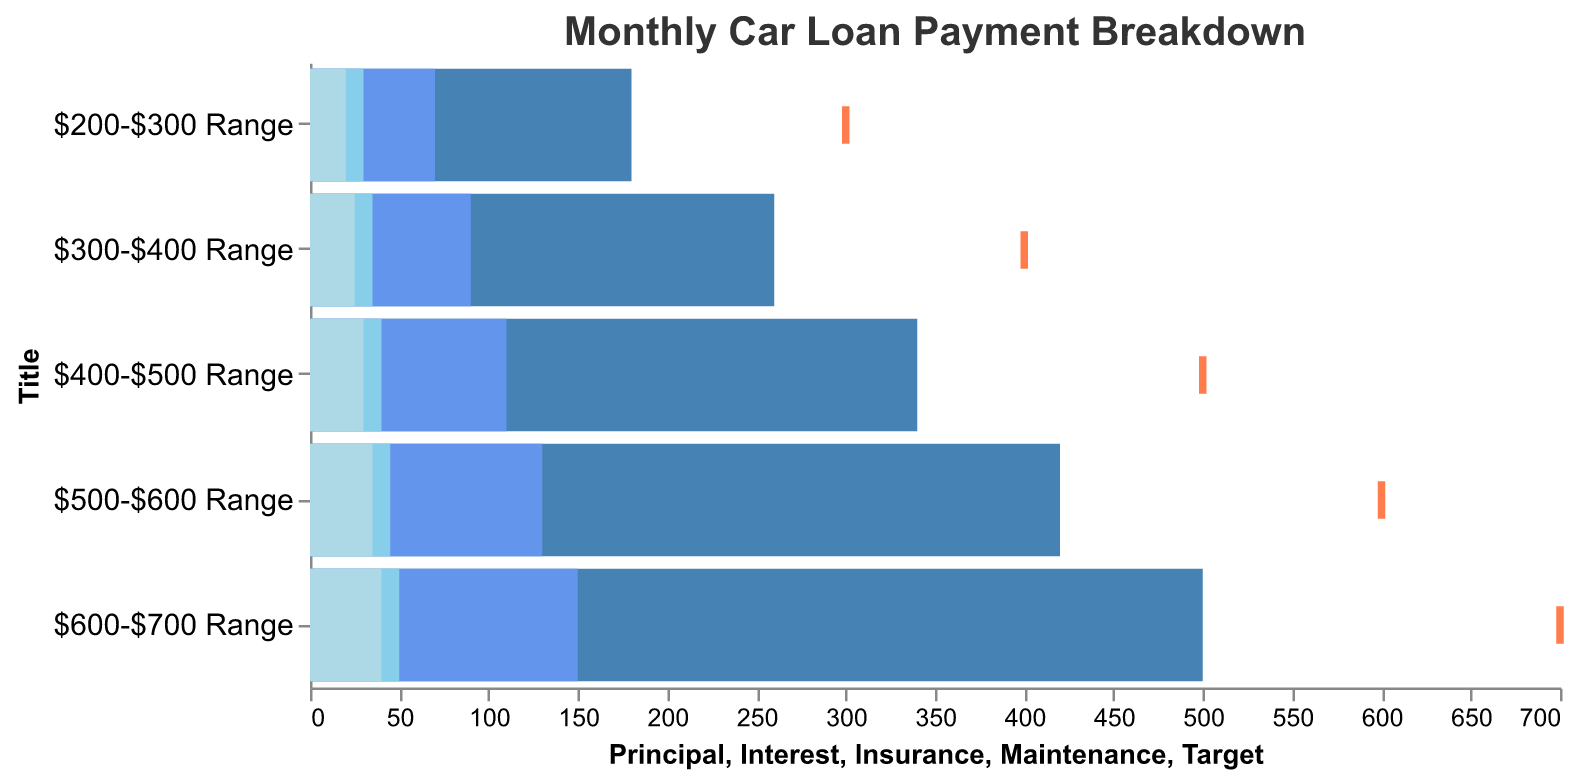How many budget ranges are represented in the figure? By counting the distinct labels on the y-axis, you can see there are 5 budget ranges represented: $200-$300, $300-$400, $400-$500, $500-$600, and $600-$700.
Answer: 5 What is the total monthly payment in the $300-$400 range? For the $300-$400 range, add up Principal ($260), Interest ($90), Insurance ($35), and Maintenance ($25) to get the total monthly payment: 260 + 90 + 35 + 25 = 410.
Answer: 410 Which budget range has the lowest principal payment? By comparing the heights of the bars corresponding to principal payments, the $200-$300 range has the lowest principal payment of $180.
Answer: $200-$300 range Is the total monthly payment in the $500-$600 range above or below the target payment? Calculate the total monthly payment in the $500-$600 range by adding Principal ($420), Interest ($130), Insurance ($45), and Maintenance ($35): 420 + 130 + 45 + 35 = 630. Then, compare it with the target payment of $600. The total monthly payment is above the target.
Answer: Above What is the difference between the actual and target total monthly payments in the $400-$500 range? Calculate the total monthly payment in the $400-$500 range by adding Principal ($340), Interest ($110), Insurance ($40), and Maintenance ($30): 340 + 110 + 40 + 30 = 520. The target payment is $500. The difference is 520 - 500 = 20.
Answer: 20 Which budget range has the highest insurance cost? Compare the Insurance values for each range. The $600-$700 range has the highest Insurance cost of $50.
Answer: $600-$700 range In which budget range does the maintenance cost make up 5% of the total payment? Calculate the total monthly payment for each range and see if the Maintenance cost forms 5% of this total. Only in the $400-$500 range does Maintenance ($30) form exactly 5% of the total payment ($30 / 520) * 100 = ~5.77%.
Answer: $400-$500 range What is the combined cost of Insurance and Maintenance in the $300-$400 range? Add the Insurance ($35) and Maintenance ($25) costs for the $300-$400 range: 35 + 25 = 60.
Answer: 60 Which budget range comes closest to meeting its target payment exactly? Compare the total payments with target payments. The $300-$400 range has a total payment of $410 with a target of $400, resulting in a difference of 10. This is the closest.
Answer: $300-$400 range 